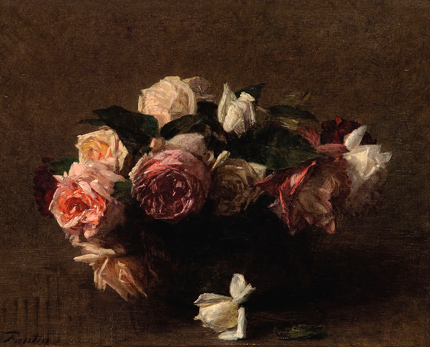Write a detailed description of the given image. The image presents a beautifully rendered oil painting that captures a striking array of roses in a bouquet. These roses vary in shades of pink, white, and red, nestling in a somber, dark-colored vase that offers a sharp contrast to the vibrant petals. The dark brown background serves not only as a neutral space that highlights the subjects but also contributes to the overall moody atmosphere of the piece. This painting is crafted in the realism style, emphasizing detailed depictions of the flowers with an almost tactile quality that invites viewers to reach out and touch the velvety petals. Additionally, the artistic rendering hints at the transience of beauty, a common theme in still life art, inviting viewers to contemplate the impermanence of life, represented by petals that will eventually wilt and fall. 